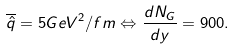<formula> <loc_0><loc_0><loc_500><loc_500>\overline { \hat { q } } = 5 G e V ^ { 2 } / f m \Leftrightarrow \frac { d N _ { G } } { d y } = 9 0 0 .</formula> 